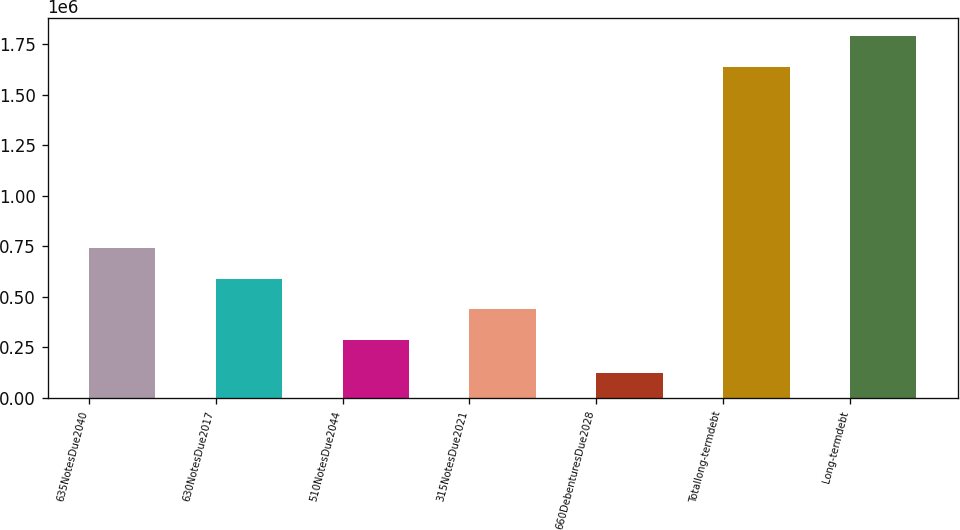<chart> <loc_0><loc_0><loc_500><loc_500><bar_chart><fcel>635NotesDue2040<fcel>630NotesDue2017<fcel>510NotesDue2044<fcel>315NotesDue2021<fcel>660DebenturesDue2028<fcel>Totallong-termdebt<fcel>Long-termdebt<nl><fcel>741844<fcel>590133<fcel>286710<fcel>438422<fcel>121269<fcel>1.63838e+06<fcel>1.7901e+06<nl></chart> 